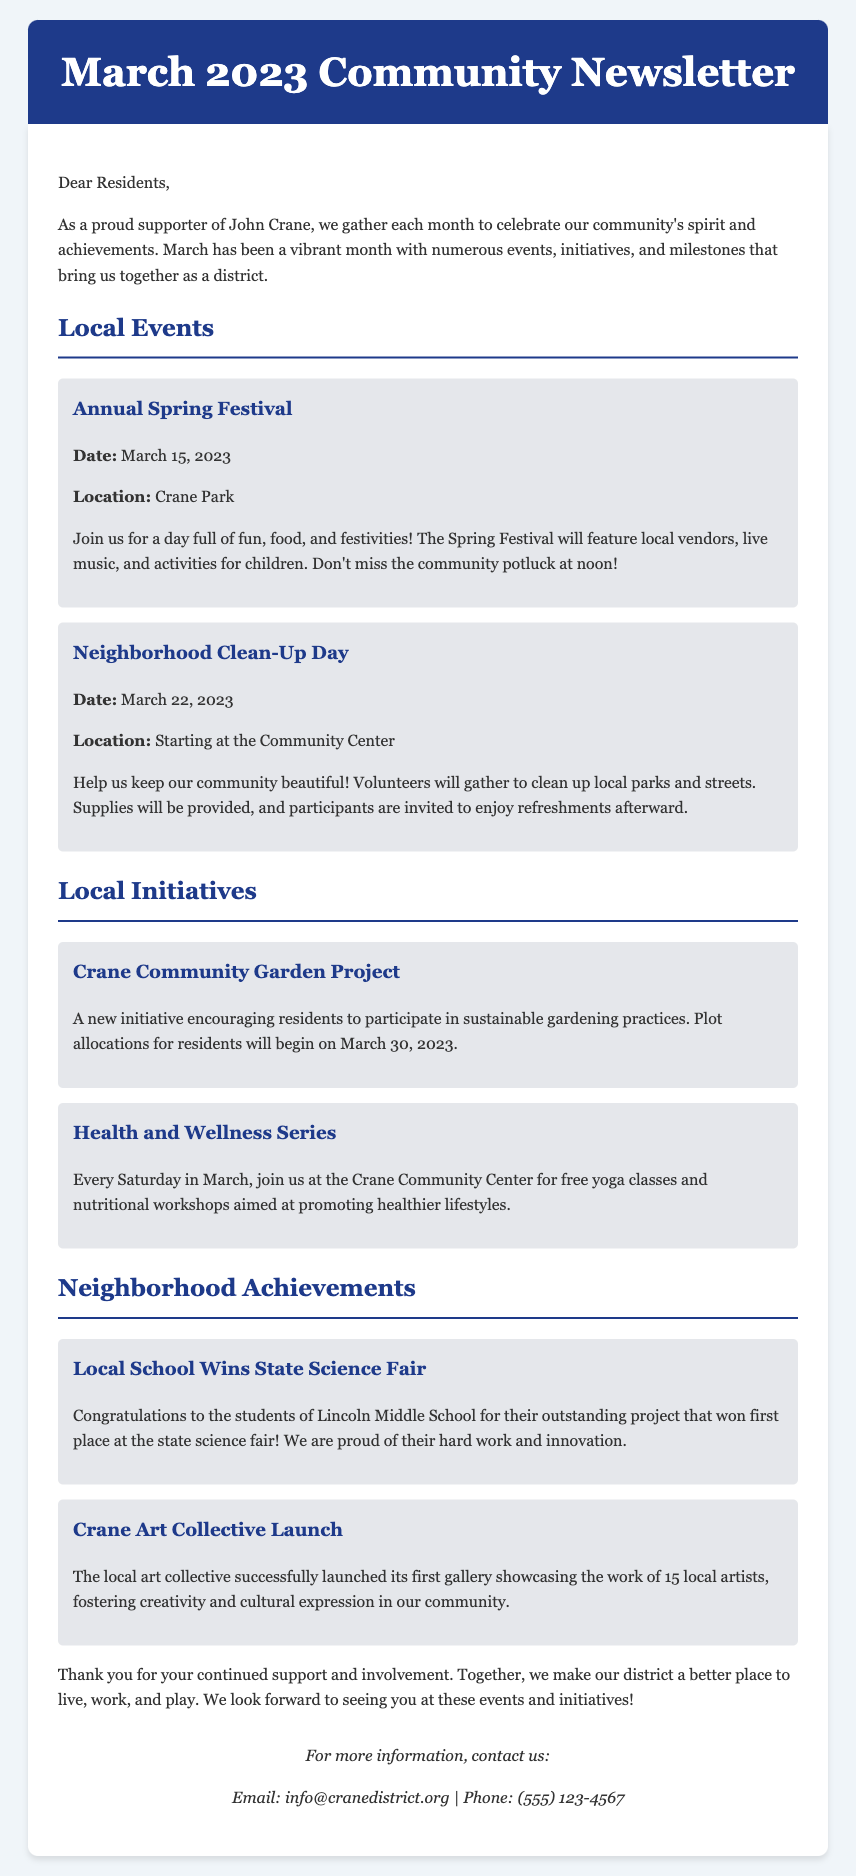What is the date of the Annual Spring Festival? The date is specifically mentioned in the event section as March 15, 2023.
Answer: March 15, 2023 Where will the Neighborhood Clean-Up Day start? The location is provided in the event section, stating it starts at the Community Center.
Answer: Community Center What is the name of the new initiative for gardening? The document mentions "Crane Community Garden Project" as the new initiative.
Answer: Crane Community Garden Project How many local artists are showcased in the Crane Art Collective? The achievement section states that the collective showcases the work of 15 local artists.
Answer: 15 What day is the beginning of plot allocations for the Crane Community Garden Project? The document specifies that plot allocations will begin on March 30, 2023.
Answer: March 30, 2023 What type of activities are included in the Health and Wellness Series? The initiative section describes it as free yoga classes and nutritional workshops.
Answer: Yoga classes and nutritional workshops What is the purpose of the Neighborhood Clean-Up Day? The event's description indicates the purpose is to keep the community beautiful.
Answer: Keep the community beautiful Which local school won the state science fair? The document states that Lincoln Middle School won the state science fair.
Answer: Lincoln Middle School 